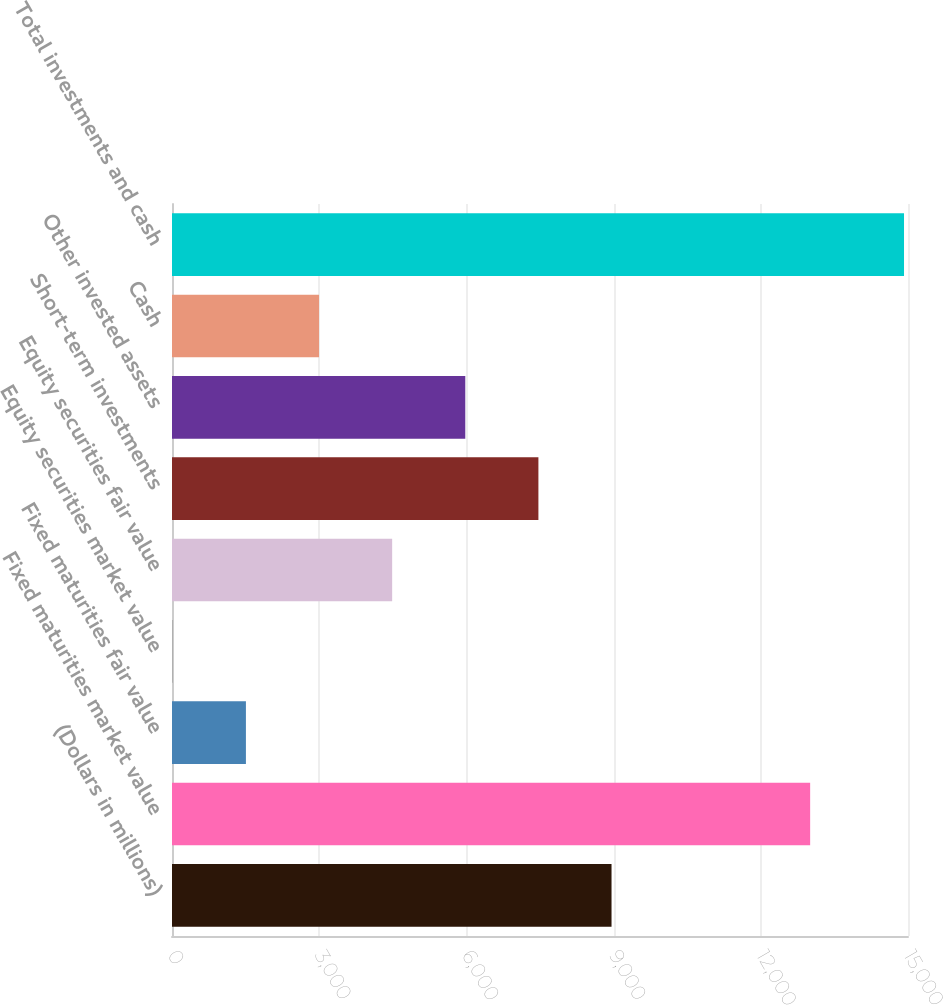<chart> <loc_0><loc_0><loc_500><loc_500><bar_chart><fcel>(Dollars in millions)<fcel>Fixed maturities market value<fcel>Fixed maturities fair value<fcel>Equity securities market value<fcel>Equity securities fair value<fcel>Short-term investments<fcel>Other invested assets<fcel>Cash<fcel>Total investments and cash<nl><fcel>8957.8<fcel>13005.9<fcel>1506.55<fcel>16.3<fcel>4487.05<fcel>7467.55<fcel>5977.3<fcel>2996.8<fcel>14918.8<nl></chart> 